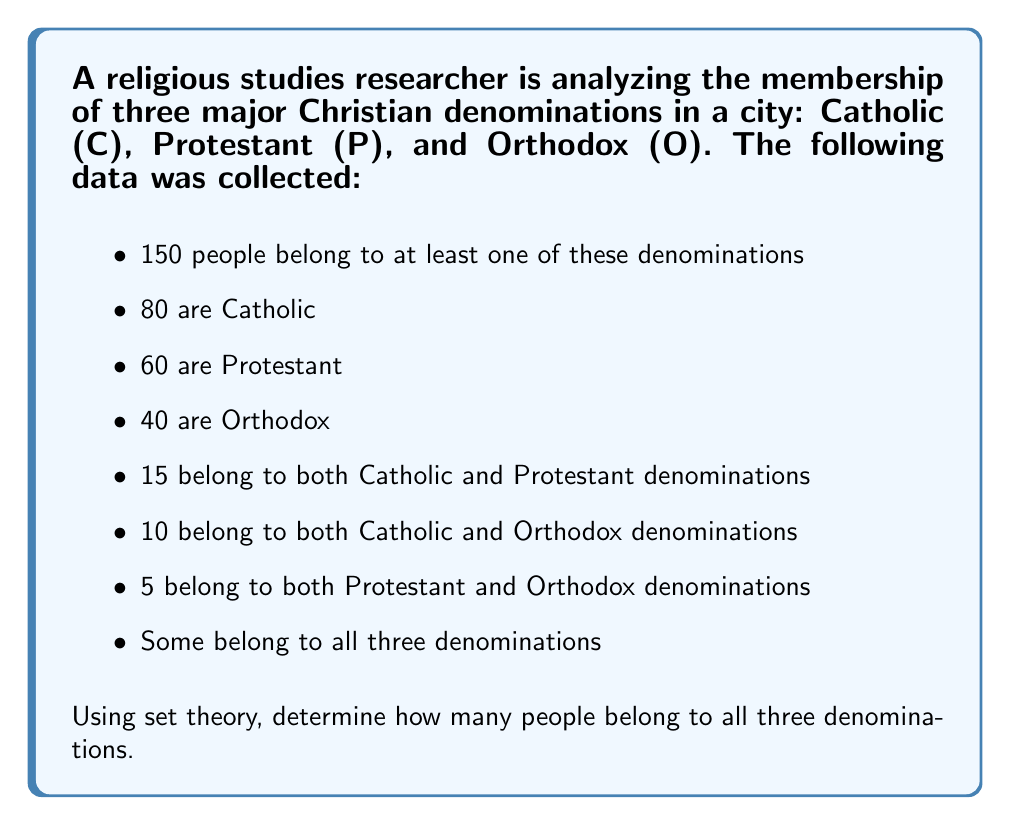Show me your answer to this math problem. Let's approach this step-by-step using set theory:

1) First, let's define our universal set U as all people belonging to at least one denomination:
   $|U| = 150$

2) We can represent the number of people in all three denominations as $|C \cap P \cap O|$

3) We can use the Inclusion-Exclusion Principle for three sets:

   $|C \cup P \cup O| = |C| + |P| + |O| - |C \cap P| - |C \cap O| - |P \cap O| + |C \cap P \cap O|$

4) We know that $|C \cup P \cup O| = |U| = 150$ (given in the problem)

5) Substituting the known values:

   $150 = 80 + 60 + 40 - 15 - 10 - 5 + |C \cap P \cap O|$

6) Now we can solve for $|C \cap P \cap O|$:

   $150 = 150 + |C \cap P \cap O|$
   $0 = |C \cap P \cap O|$

Therefore, the number of people belonging to all three denominations is 0.

This result makes sense in the context of set theory and religious studies. It shows that while there are overlaps between pairs of denominations, in this particular city, no individual belongs to all three denominations simultaneously, which is a realistic scenario given the significant theological differences between these branches of Christianity.
Answer: 0 people belong to all three denominations. 